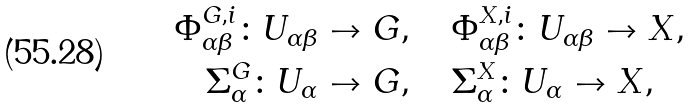<formula> <loc_0><loc_0><loc_500><loc_500>\Phi _ { \alpha \beta } ^ { G , i } \colon U _ { \alpha \beta } & \to G , \quad \Phi _ { \alpha \beta } ^ { X , i } \colon U _ { \alpha \beta } \to X , \\ \Sigma _ { \alpha } ^ { G } \colon U _ { \alpha } & \to G , \quad \Sigma _ { \alpha } ^ { X } \colon U _ { \alpha } \to X ,</formula> 